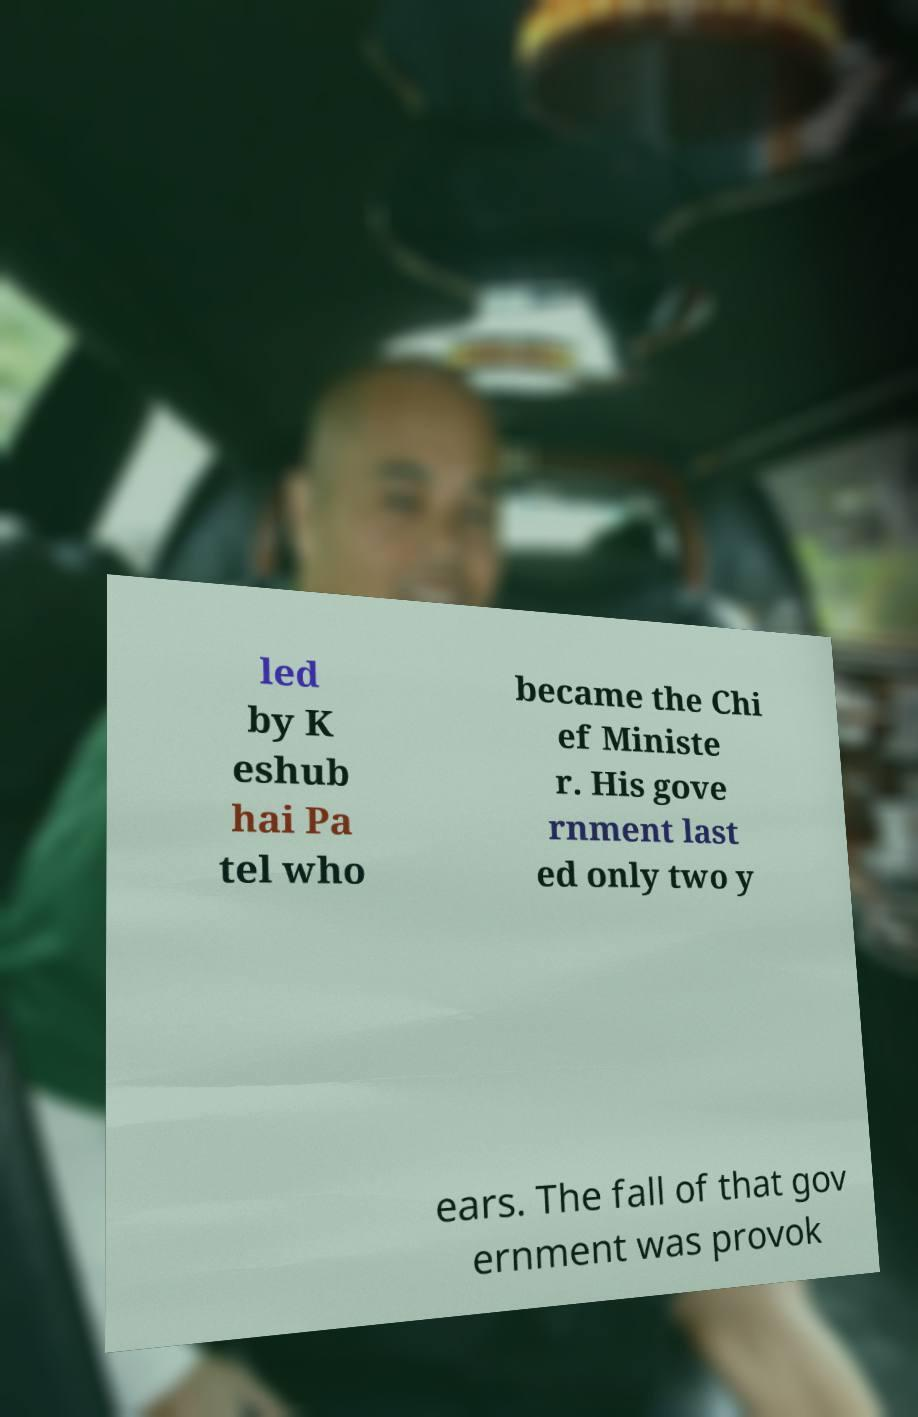Could you assist in decoding the text presented in this image and type it out clearly? led by K eshub hai Pa tel who became the Chi ef Ministe r. His gove rnment last ed only two y ears. The fall of that gov ernment was provok 